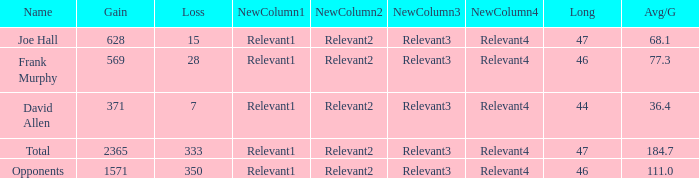How much Avg/G has a Gain smaller than 1571, and a Long smaller than 46? 1.0. 